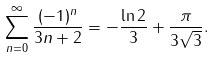Convert formula to latex. <formula><loc_0><loc_0><loc_500><loc_500>\sum _ { n = 0 } ^ { \infty } { \frac { ( - 1 ) ^ { n } } { 3 n + 2 } } = - { \frac { \ln 2 } { 3 } } + { \frac { \pi } { 3 { \sqrt { 3 } } } } .</formula> 